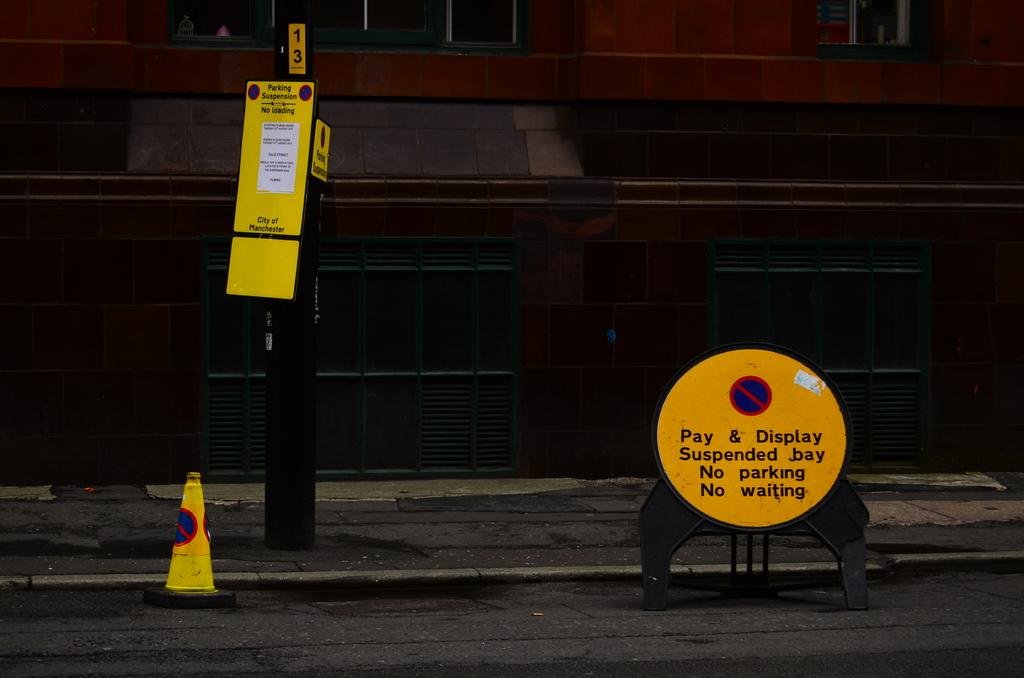<image>
Create a compact narrative representing the image presented. No loading is allowed in the area according to the signs. 